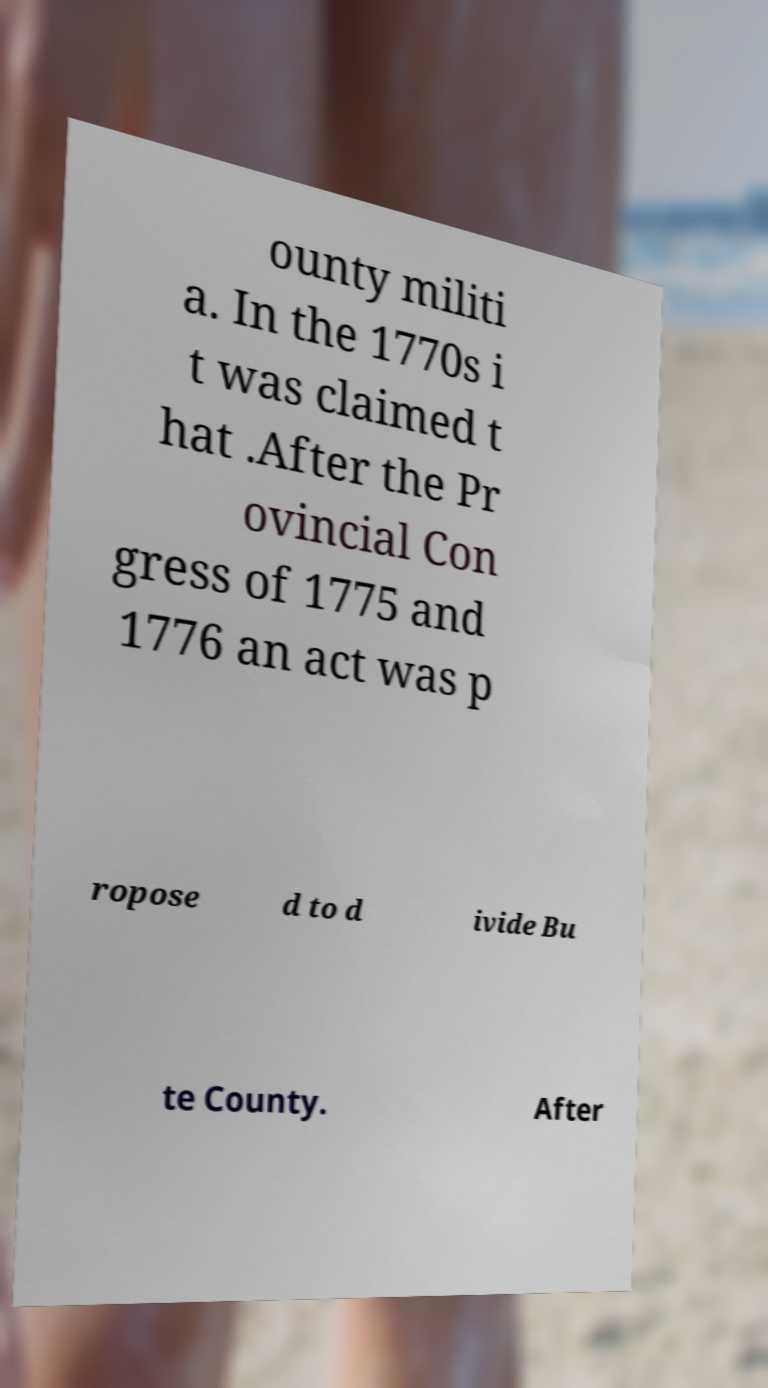Please read and relay the text visible in this image. What does it say? ounty militi a. In the 1770s i t was claimed t hat .After the Pr ovincial Con gress of 1775 and 1776 an act was p ropose d to d ivide Bu te County. After 